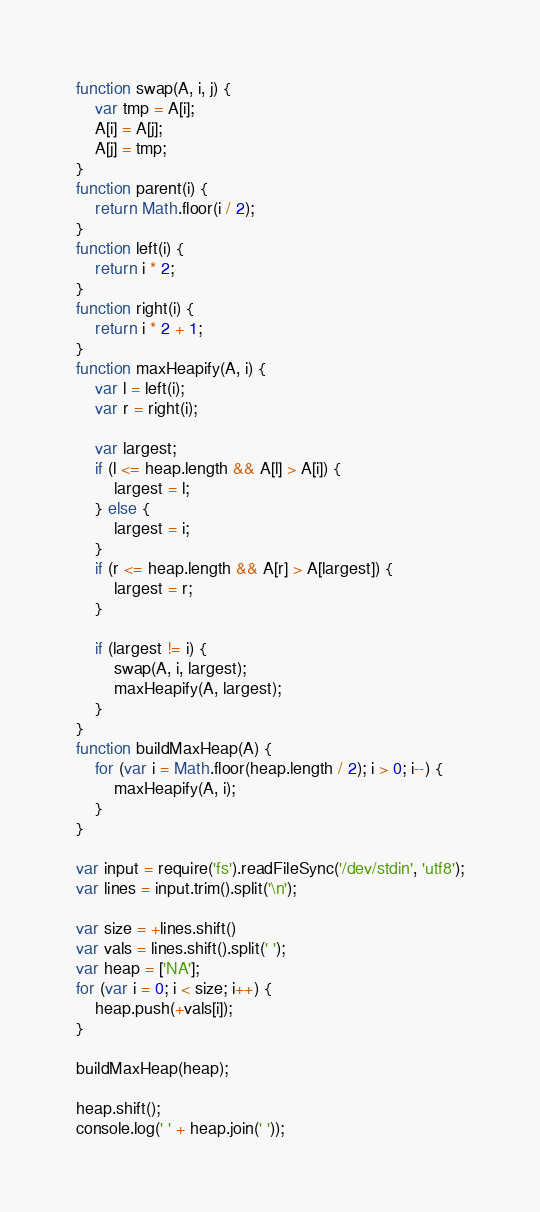<code> <loc_0><loc_0><loc_500><loc_500><_JavaScript_>function swap(A, i, j) {
	var tmp = A[i];
	A[i] = A[j];
	A[j] = tmp;
}
function parent(i) {
	return Math.floor(i / 2);
}
function left(i) {
	return i * 2;
}
function right(i) {
	return i * 2 + 1;
}
function maxHeapify(A, i) {
	var l = left(i);
	var r = right(i);

	var largest;
	if (l <= heap.length && A[l] > A[i]) {
		largest = l;
	} else {
		largest = i;
	}
	if (r <= heap.length && A[r] > A[largest]) {
		largest = r;
	}

	if (largest != i) {
		swap(A, i, largest);
		maxHeapify(A, largest);
	}
}
function buildMaxHeap(A) {
	for (var i = Math.floor(heap.length / 2); i > 0; i--) {
		maxHeapify(A, i);
	}
}

var input = require('fs').readFileSync('/dev/stdin', 'utf8');
var lines = input.trim().split('\n');

var size = +lines.shift()
var vals = lines.shift().split(' ');
var heap = ['NA'];
for (var i = 0; i < size; i++) {
	heap.push(+vals[i]);
}

buildMaxHeap(heap);

heap.shift();
console.log(' ' + heap.join(' '));</code> 